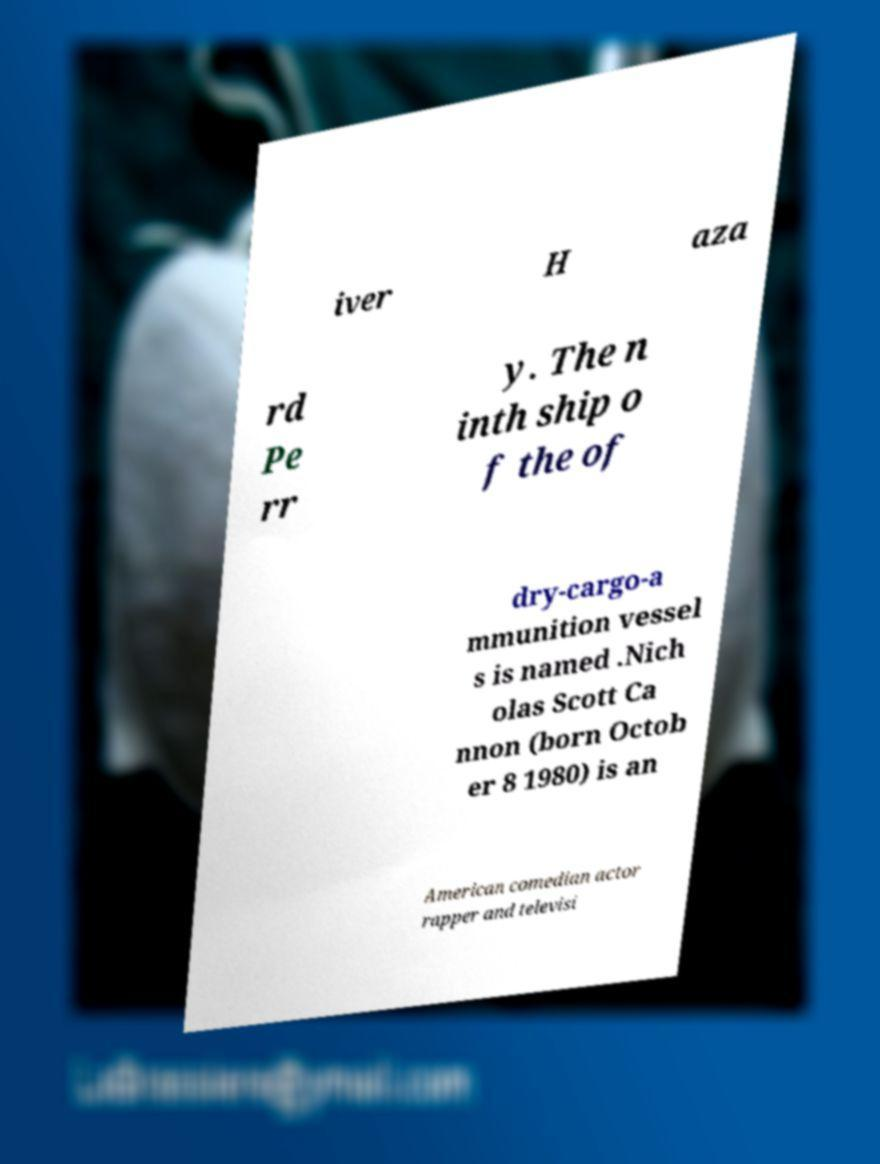Could you assist in decoding the text presented in this image and type it out clearly? iver H aza rd Pe rr y. The n inth ship o f the of dry-cargo-a mmunition vessel s is named .Nich olas Scott Ca nnon (born Octob er 8 1980) is an American comedian actor rapper and televisi 